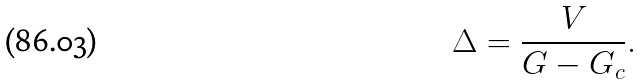<formula> <loc_0><loc_0><loc_500><loc_500>\Delta = \frac { V } { G - G _ { c } } .</formula> 